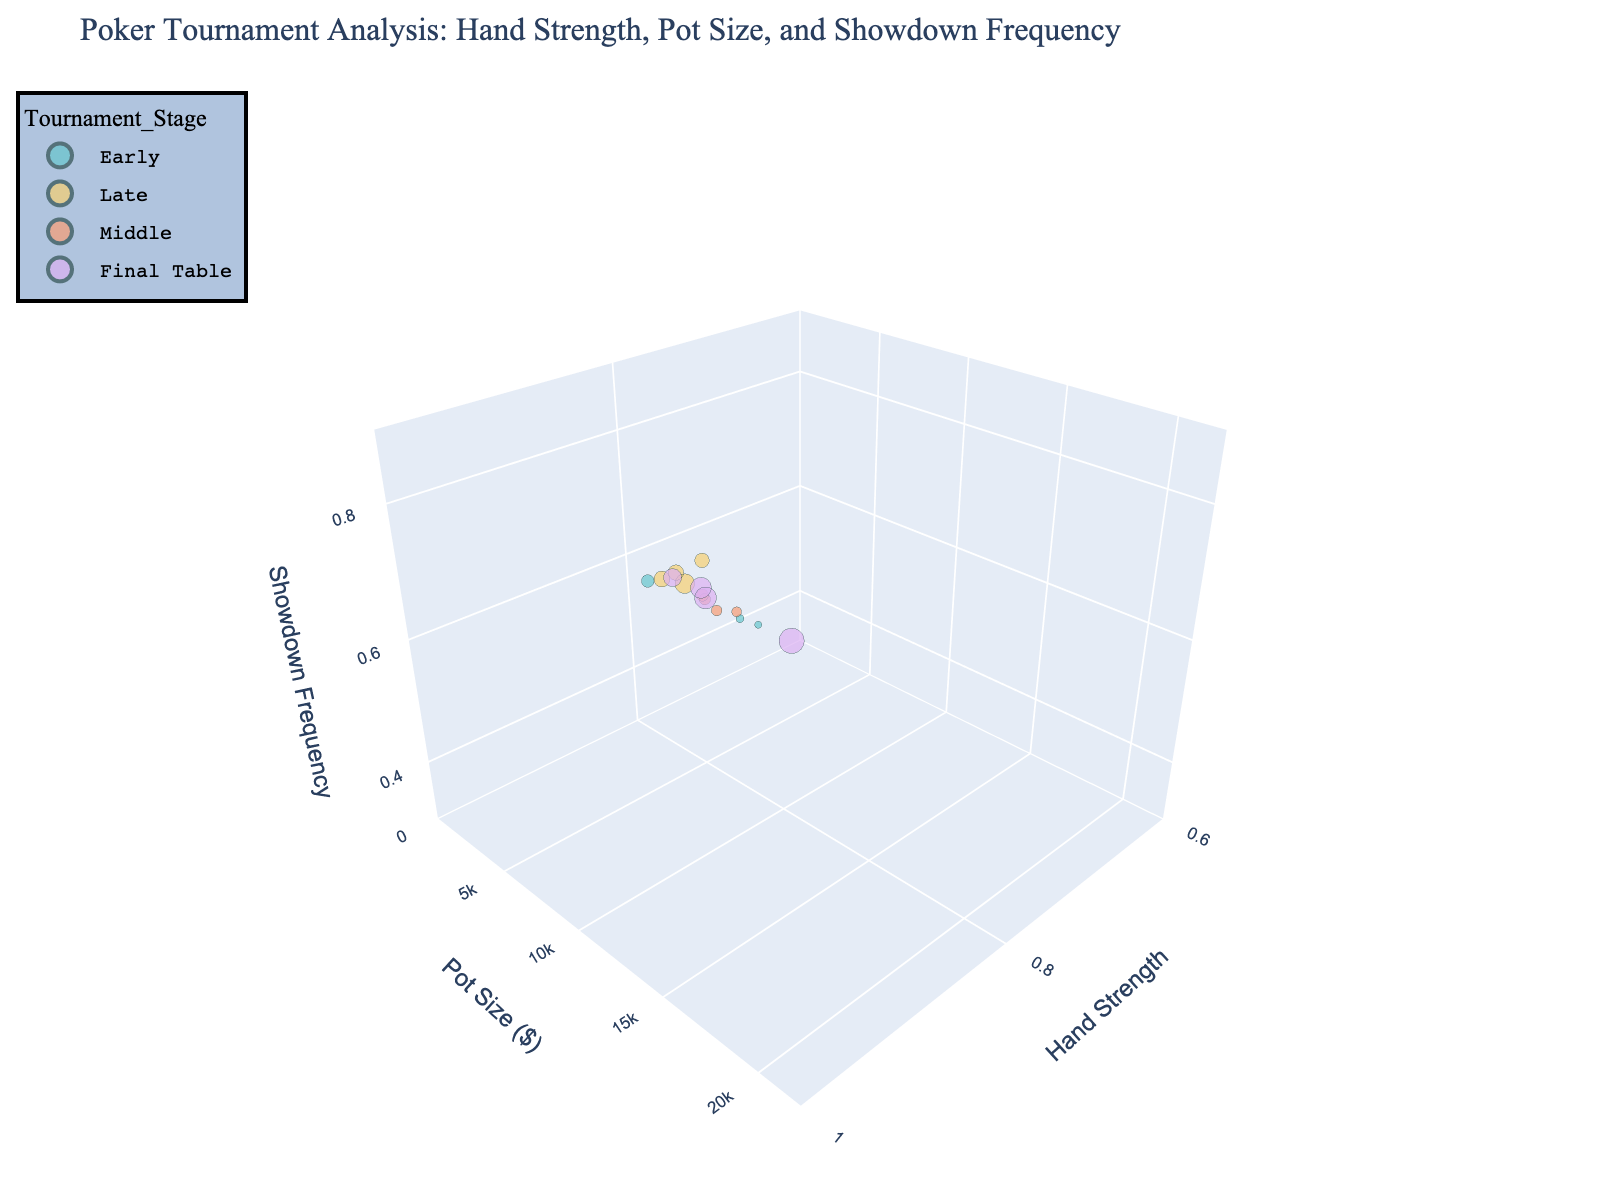What's the title of the figure? The title is always positioned at the top of the figure and it usually summarizes the content of the plot. In this case, looking at the top area of the plot shows "Poker Tournament Analysis: Hand Strength, Pot Size, and Showdown Frequency".
Answer: Poker Tournament Analysis: Hand Strength, Pot Size, and Showdown Frequency How many Tournament Stages are represented in the plot? By examining the legend on the plot and observing the colors, we see distinct groups: Early, Middle, Late, and Final Table. Counting these groups gives us the total number of stages.
Answer: 4 What is the range of the Pot Size axis? The range of the axis for Pot Size can be found by looking at the y-axis of the 3D scatter plot. It spans from 0 to 22,000 dollars.
Answer: 0 to 22,000 dollars Which Tournament Stage has the highest Showdown Frequency? By observing the z-axis and searching for the highest point, we can match the color of this point to the Tournament Stage shown in the legend. The highest Showdown Frequency is at 0.85, which corresponds to the 'Final Table' stage.
Answer: Final Table What is the average Hand Strength in the Late stage? To find this, identify all the data points colored for the 'Late' stage in the legend. Sum their respective Hand Strength values and divide by the number of these points. The values for 'Late' stage are 0.92, 0.88, 0.82, and 0.86. (0.92 + 0.88 + 0.82 + 0.86) / 4 = 0.87
Answer: 0.87 Do any data points have a Pot Size above 15,000 dollars? Observe the y-axis and check if any points are above the 15,000 mark. There are indeed points at 20,000 and 15,000 dollars Pot Size.
Answer: Yes What's the difference in Showdown Frequency between the highest and lowest data points? By looking at the z-axis, identify the highest point (0.85) and the lowest point (0.41). Subtract the lowest from the highest: 0.85 - 0.41.
Answer: 0.44 Which Tournament Stage generally has the highest Pot Sizes? Observing the y-axis and correlating the heights of clusters based on their color groups in the legend, 'Final Table' generally features the highest Pot Sizes.
Answer: Final Table Is there a correlation between Hand Strength and Pot Size? By observing the scatter plot, we look for a pattern between Hand Strength (x-axis) and Pot Size (y-axis). It appears that higher Hand Strength values are often associated with higher Pot Sizes, indicating a positive correlation.
Answer: Positive correlation How does the Showdown Frequency vary from the Early to Final Table stages? Follow Showdown Frequency (z-axis) through different stages. We see a lower frequency in 'Early', then values tend to increase as we move to 'Middle', 'Late', and peak at 'Final Table'.
Answer: Increases from Early to Final Table 